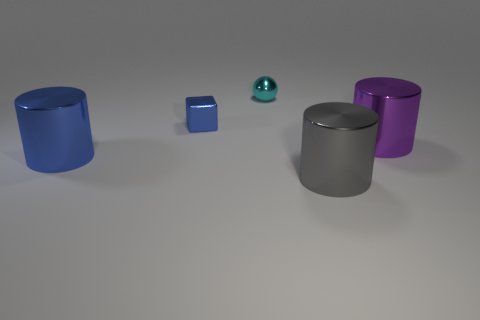Subtract all spheres. How many objects are left? 4 Add 1 tiny things. How many tiny things exist? 3 Add 2 large blue things. How many objects exist? 7 Subtract all blue cylinders. How many cylinders are left? 2 Subtract 0 brown blocks. How many objects are left? 5 Subtract 2 cylinders. How many cylinders are left? 1 Subtract all purple cylinders. Subtract all green balls. How many cylinders are left? 2 Subtract all blue balls. How many gray cylinders are left? 1 Subtract all small blue matte cylinders. Subtract all small cyan shiny objects. How many objects are left? 4 Add 5 purple shiny objects. How many purple shiny objects are left? 6 